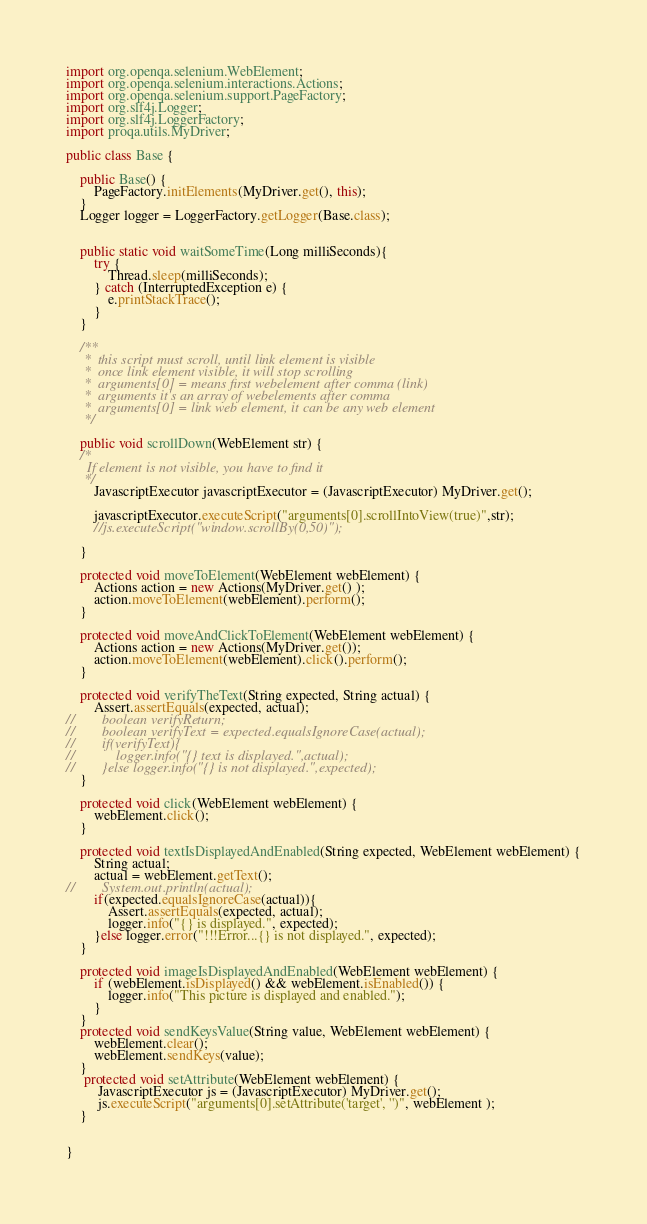<code> <loc_0><loc_0><loc_500><loc_500><_Java_>import org.openqa.selenium.WebElement;
import org.openqa.selenium.interactions.Actions;
import org.openqa.selenium.support.PageFactory;
import org.slf4j.Logger;
import org.slf4j.LoggerFactory;
import proqa.utils.MyDriver;

public class Base {

    public Base() {
        PageFactory.initElements(MyDriver.get(), this);
    }
    Logger logger = LoggerFactory.getLogger(Base.class);


    public static void waitSomeTime(Long milliSeconds){
        try {
            Thread.sleep(milliSeconds);
        } catch (InterruptedException e) {
            e.printStackTrace();
        }
    }

    /**
     *  this script must scroll, until link element is visible
     *  once link element visible, it will stop scrolling
     *  arguments[0] = means first webelement after comma (link)
     *  arguments it's an array of webelements after comma
     *  arguments[0] = link web element, it can be any web element
     */

    public void scrollDown(WebElement str) {
    /*
      If element is not visible, you have to find it
     */
        JavascriptExecutor javascriptExecutor = (JavascriptExecutor) MyDriver.get();

        javascriptExecutor.executeScript("arguments[0].scrollIntoView(true)",str);
        //js.executeScript("window.scrollBy(0,50)");

    }

    protected void moveToElement(WebElement webElement) {
        Actions action = new Actions(MyDriver.get() );
        action.moveToElement(webElement).perform();
    }

    protected void moveAndClickToElement(WebElement webElement) {
        Actions action = new Actions(MyDriver.get());
        action.moveToElement(webElement).click().perform();
    }

    protected void verifyTheText(String expected, String actual) {
        Assert.assertEquals(expected, actual);
//        boolean verifyReturn;
//        boolean verifyText = expected.equalsIgnoreCase(actual);
//        if(verifyText){
//            logger.info("{} text is displayed.",actual);
//        }else logger.info("{} is not displayed.",expected);
    }

    protected void click(WebElement webElement) {
        webElement.click();
    }

    protected void textIsDisplayedAndEnabled(String expected, WebElement webElement) {
        String actual;
        actual = webElement.getText();
//        System.out.println(actual);
        if(expected.equalsIgnoreCase(actual)){
            Assert.assertEquals(expected, actual);
            logger.info("{} is displayed.", expected);
        }else logger.error("!!!Error...{} is not displayed.", expected);
    }

    protected void imageIsDisplayedAndEnabled(WebElement webElement) {
        if (webElement.isDisplayed() && webElement.isEnabled()) {
            logger.info("This picture is displayed and enabled.");
        }
    }
    protected void sendKeysValue(String value, WebElement webElement) {
        webElement.clear();
        webElement.sendKeys(value);
    }
     protected void setAttribute(WebElement webElement) {
         JavascriptExecutor js = (JavascriptExecutor) MyDriver.get();
         js.executeScript("arguments[0].setAttribute('target', '')", webElement );
    }


}
</code> 